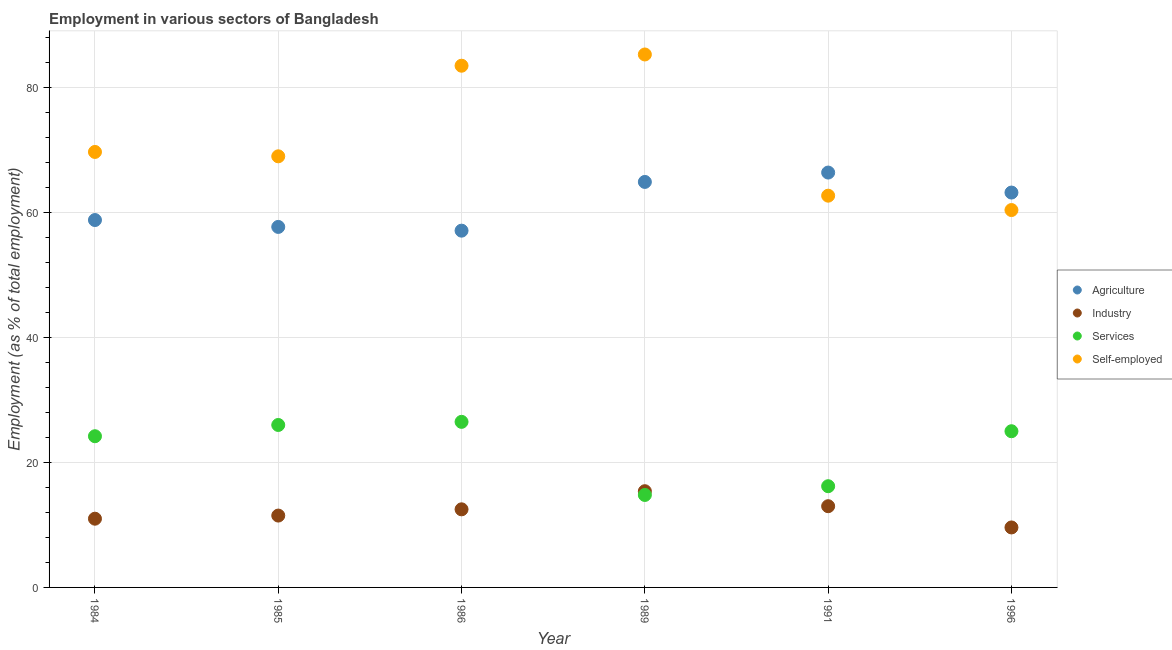How many different coloured dotlines are there?
Give a very brief answer. 4. What is the percentage of workers in industry in 1986?
Your response must be concise. 12.5. Across all years, what is the maximum percentage of workers in agriculture?
Your response must be concise. 66.4. Across all years, what is the minimum percentage of workers in agriculture?
Keep it short and to the point. 57.1. In which year was the percentage of workers in agriculture maximum?
Offer a very short reply. 1991. In which year was the percentage of workers in industry minimum?
Provide a succinct answer. 1996. What is the total percentage of workers in industry in the graph?
Make the answer very short. 73. What is the difference between the percentage of workers in industry in 1984 and that in 1996?
Keep it short and to the point. 1.4. What is the difference between the percentage of workers in services in 1984 and the percentage of workers in industry in 1991?
Keep it short and to the point. 11.2. What is the average percentage of workers in services per year?
Your answer should be very brief. 22.12. In the year 1991, what is the difference between the percentage of workers in services and percentage of self employed workers?
Offer a terse response. -46.5. In how many years, is the percentage of workers in agriculture greater than 4 %?
Make the answer very short. 6. What is the ratio of the percentage of workers in industry in 1986 to that in 1989?
Provide a succinct answer. 0.81. Is the percentage of workers in services in 1985 less than that in 1991?
Your answer should be compact. No. Is the difference between the percentage of workers in services in 1984 and 1985 greater than the difference between the percentage of workers in agriculture in 1984 and 1985?
Offer a terse response. No. What is the difference between the highest and the lowest percentage of workers in services?
Provide a short and direct response. 11.7. In how many years, is the percentage of self employed workers greater than the average percentage of self employed workers taken over all years?
Offer a terse response. 2. Is the sum of the percentage of self employed workers in 1986 and 1991 greater than the maximum percentage of workers in services across all years?
Ensure brevity in your answer.  Yes. Is it the case that in every year, the sum of the percentage of workers in services and percentage of workers in industry is greater than the sum of percentage of self employed workers and percentage of workers in agriculture?
Your answer should be very brief. No. Is the percentage of self employed workers strictly greater than the percentage of workers in agriculture over the years?
Make the answer very short. No. How many dotlines are there?
Give a very brief answer. 4. How many years are there in the graph?
Your answer should be very brief. 6. Where does the legend appear in the graph?
Your answer should be compact. Center right. How many legend labels are there?
Offer a very short reply. 4. What is the title of the graph?
Your answer should be compact. Employment in various sectors of Bangladesh. Does "Fish species" appear as one of the legend labels in the graph?
Provide a short and direct response. No. What is the label or title of the X-axis?
Keep it short and to the point. Year. What is the label or title of the Y-axis?
Give a very brief answer. Employment (as % of total employment). What is the Employment (as % of total employment) of Agriculture in 1984?
Give a very brief answer. 58.8. What is the Employment (as % of total employment) in Industry in 1984?
Give a very brief answer. 11. What is the Employment (as % of total employment) in Services in 1984?
Your answer should be compact. 24.2. What is the Employment (as % of total employment) of Self-employed in 1984?
Make the answer very short. 69.7. What is the Employment (as % of total employment) in Agriculture in 1985?
Make the answer very short. 57.7. What is the Employment (as % of total employment) of Industry in 1985?
Provide a succinct answer. 11.5. What is the Employment (as % of total employment) in Agriculture in 1986?
Ensure brevity in your answer.  57.1. What is the Employment (as % of total employment) of Industry in 1986?
Keep it short and to the point. 12.5. What is the Employment (as % of total employment) of Self-employed in 1986?
Make the answer very short. 83.5. What is the Employment (as % of total employment) of Agriculture in 1989?
Provide a short and direct response. 64.9. What is the Employment (as % of total employment) in Industry in 1989?
Keep it short and to the point. 15.4. What is the Employment (as % of total employment) in Services in 1989?
Ensure brevity in your answer.  14.8. What is the Employment (as % of total employment) in Self-employed in 1989?
Provide a succinct answer. 85.3. What is the Employment (as % of total employment) of Agriculture in 1991?
Provide a succinct answer. 66.4. What is the Employment (as % of total employment) of Industry in 1991?
Provide a succinct answer. 13. What is the Employment (as % of total employment) in Services in 1991?
Keep it short and to the point. 16.2. What is the Employment (as % of total employment) of Self-employed in 1991?
Provide a short and direct response. 62.7. What is the Employment (as % of total employment) in Agriculture in 1996?
Keep it short and to the point. 63.2. What is the Employment (as % of total employment) in Industry in 1996?
Offer a terse response. 9.6. What is the Employment (as % of total employment) in Self-employed in 1996?
Your answer should be very brief. 60.4. Across all years, what is the maximum Employment (as % of total employment) in Agriculture?
Offer a very short reply. 66.4. Across all years, what is the maximum Employment (as % of total employment) in Industry?
Your answer should be compact. 15.4. Across all years, what is the maximum Employment (as % of total employment) of Services?
Make the answer very short. 26.5. Across all years, what is the maximum Employment (as % of total employment) of Self-employed?
Provide a short and direct response. 85.3. Across all years, what is the minimum Employment (as % of total employment) of Agriculture?
Make the answer very short. 57.1. Across all years, what is the minimum Employment (as % of total employment) in Industry?
Make the answer very short. 9.6. Across all years, what is the minimum Employment (as % of total employment) in Services?
Ensure brevity in your answer.  14.8. Across all years, what is the minimum Employment (as % of total employment) of Self-employed?
Your answer should be very brief. 60.4. What is the total Employment (as % of total employment) in Agriculture in the graph?
Give a very brief answer. 368.1. What is the total Employment (as % of total employment) of Services in the graph?
Provide a short and direct response. 132.7. What is the total Employment (as % of total employment) in Self-employed in the graph?
Ensure brevity in your answer.  430.6. What is the difference between the Employment (as % of total employment) in Services in 1984 and that in 1986?
Your answer should be compact. -2.3. What is the difference between the Employment (as % of total employment) of Services in 1984 and that in 1989?
Offer a terse response. 9.4. What is the difference between the Employment (as % of total employment) of Self-employed in 1984 and that in 1989?
Offer a terse response. -15.6. What is the difference between the Employment (as % of total employment) of Services in 1984 and that in 1991?
Ensure brevity in your answer.  8. What is the difference between the Employment (as % of total employment) in Industry in 1984 and that in 1996?
Your response must be concise. 1.4. What is the difference between the Employment (as % of total employment) in Self-employed in 1984 and that in 1996?
Give a very brief answer. 9.3. What is the difference between the Employment (as % of total employment) in Agriculture in 1985 and that in 1986?
Your response must be concise. 0.6. What is the difference between the Employment (as % of total employment) of Services in 1985 and that in 1986?
Provide a succinct answer. -0.5. What is the difference between the Employment (as % of total employment) in Industry in 1985 and that in 1989?
Make the answer very short. -3.9. What is the difference between the Employment (as % of total employment) in Services in 1985 and that in 1989?
Your response must be concise. 11.2. What is the difference between the Employment (as % of total employment) of Self-employed in 1985 and that in 1989?
Provide a succinct answer. -16.3. What is the difference between the Employment (as % of total employment) in Industry in 1985 and that in 1991?
Offer a very short reply. -1.5. What is the difference between the Employment (as % of total employment) in Self-employed in 1985 and that in 1991?
Keep it short and to the point. 6.3. What is the difference between the Employment (as % of total employment) in Services in 1985 and that in 1996?
Keep it short and to the point. 1. What is the difference between the Employment (as % of total employment) in Self-employed in 1985 and that in 1996?
Make the answer very short. 8.6. What is the difference between the Employment (as % of total employment) in Agriculture in 1986 and that in 1989?
Offer a terse response. -7.8. What is the difference between the Employment (as % of total employment) in Self-employed in 1986 and that in 1989?
Provide a short and direct response. -1.8. What is the difference between the Employment (as % of total employment) of Agriculture in 1986 and that in 1991?
Your answer should be compact. -9.3. What is the difference between the Employment (as % of total employment) in Self-employed in 1986 and that in 1991?
Offer a terse response. 20.8. What is the difference between the Employment (as % of total employment) of Industry in 1986 and that in 1996?
Your answer should be compact. 2.9. What is the difference between the Employment (as % of total employment) of Services in 1986 and that in 1996?
Ensure brevity in your answer.  1.5. What is the difference between the Employment (as % of total employment) of Self-employed in 1986 and that in 1996?
Keep it short and to the point. 23.1. What is the difference between the Employment (as % of total employment) of Agriculture in 1989 and that in 1991?
Make the answer very short. -1.5. What is the difference between the Employment (as % of total employment) of Self-employed in 1989 and that in 1991?
Your answer should be compact. 22.6. What is the difference between the Employment (as % of total employment) of Industry in 1989 and that in 1996?
Make the answer very short. 5.8. What is the difference between the Employment (as % of total employment) of Self-employed in 1989 and that in 1996?
Ensure brevity in your answer.  24.9. What is the difference between the Employment (as % of total employment) of Agriculture in 1991 and that in 1996?
Provide a succinct answer. 3.2. What is the difference between the Employment (as % of total employment) of Self-employed in 1991 and that in 1996?
Keep it short and to the point. 2.3. What is the difference between the Employment (as % of total employment) of Agriculture in 1984 and the Employment (as % of total employment) of Industry in 1985?
Ensure brevity in your answer.  47.3. What is the difference between the Employment (as % of total employment) in Agriculture in 1984 and the Employment (as % of total employment) in Services in 1985?
Offer a very short reply. 32.8. What is the difference between the Employment (as % of total employment) of Industry in 1984 and the Employment (as % of total employment) of Services in 1985?
Your answer should be compact. -15. What is the difference between the Employment (as % of total employment) of Industry in 1984 and the Employment (as % of total employment) of Self-employed in 1985?
Offer a terse response. -58. What is the difference between the Employment (as % of total employment) in Services in 1984 and the Employment (as % of total employment) in Self-employed in 1985?
Ensure brevity in your answer.  -44.8. What is the difference between the Employment (as % of total employment) of Agriculture in 1984 and the Employment (as % of total employment) of Industry in 1986?
Offer a very short reply. 46.3. What is the difference between the Employment (as % of total employment) in Agriculture in 1984 and the Employment (as % of total employment) in Services in 1986?
Make the answer very short. 32.3. What is the difference between the Employment (as % of total employment) in Agriculture in 1984 and the Employment (as % of total employment) in Self-employed in 1986?
Your answer should be compact. -24.7. What is the difference between the Employment (as % of total employment) in Industry in 1984 and the Employment (as % of total employment) in Services in 1986?
Give a very brief answer. -15.5. What is the difference between the Employment (as % of total employment) in Industry in 1984 and the Employment (as % of total employment) in Self-employed in 1986?
Make the answer very short. -72.5. What is the difference between the Employment (as % of total employment) of Services in 1984 and the Employment (as % of total employment) of Self-employed in 1986?
Keep it short and to the point. -59.3. What is the difference between the Employment (as % of total employment) of Agriculture in 1984 and the Employment (as % of total employment) of Industry in 1989?
Offer a terse response. 43.4. What is the difference between the Employment (as % of total employment) of Agriculture in 1984 and the Employment (as % of total employment) of Services in 1989?
Keep it short and to the point. 44. What is the difference between the Employment (as % of total employment) in Agriculture in 1984 and the Employment (as % of total employment) in Self-employed in 1989?
Make the answer very short. -26.5. What is the difference between the Employment (as % of total employment) of Industry in 1984 and the Employment (as % of total employment) of Services in 1989?
Give a very brief answer. -3.8. What is the difference between the Employment (as % of total employment) of Industry in 1984 and the Employment (as % of total employment) of Self-employed in 1989?
Your answer should be very brief. -74.3. What is the difference between the Employment (as % of total employment) in Services in 1984 and the Employment (as % of total employment) in Self-employed in 1989?
Your answer should be compact. -61.1. What is the difference between the Employment (as % of total employment) of Agriculture in 1984 and the Employment (as % of total employment) of Industry in 1991?
Provide a short and direct response. 45.8. What is the difference between the Employment (as % of total employment) of Agriculture in 1984 and the Employment (as % of total employment) of Services in 1991?
Offer a very short reply. 42.6. What is the difference between the Employment (as % of total employment) of Agriculture in 1984 and the Employment (as % of total employment) of Self-employed in 1991?
Provide a succinct answer. -3.9. What is the difference between the Employment (as % of total employment) in Industry in 1984 and the Employment (as % of total employment) in Self-employed in 1991?
Your response must be concise. -51.7. What is the difference between the Employment (as % of total employment) of Services in 1984 and the Employment (as % of total employment) of Self-employed in 1991?
Provide a short and direct response. -38.5. What is the difference between the Employment (as % of total employment) in Agriculture in 1984 and the Employment (as % of total employment) in Industry in 1996?
Offer a terse response. 49.2. What is the difference between the Employment (as % of total employment) of Agriculture in 1984 and the Employment (as % of total employment) of Services in 1996?
Provide a short and direct response. 33.8. What is the difference between the Employment (as % of total employment) of Industry in 1984 and the Employment (as % of total employment) of Services in 1996?
Your answer should be compact. -14. What is the difference between the Employment (as % of total employment) of Industry in 1984 and the Employment (as % of total employment) of Self-employed in 1996?
Your answer should be very brief. -49.4. What is the difference between the Employment (as % of total employment) of Services in 1984 and the Employment (as % of total employment) of Self-employed in 1996?
Provide a succinct answer. -36.2. What is the difference between the Employment (as % of total employment) of Agriculture in 1985 and the Employment (as % of total employment) of Industry in 1986?
Ensure brevity in your answer.  45.2. What is the difference between the Employment (as % of total employment) of Agriculture in 1985 and the Employment (as % of total employment) of Services in 1986?
Provide a short and direct response. 31.2. What is the difference between the Employment (as % of total employment) of Agriculture in 1985 and the Employment (as % of total employment) of Self-employed in 1986?
Offer a very short reply. -25.8. What is the difference between the Employment (as % of total employment) of Industry in 1985 and the Employment (as % of total employment) of Self-employed in 1986?
Offer a very short reply. -72. What is the difference between the Employment (as % of total employment) of Services in 1985 and the Employment (as % of total employment) of Self-employed in 1986?
Offer a terse response. -57.5. What is the difference between the Employment (as % of total employment) in Agriculture in 1985 and the Employment (as % of total employment) in Industry in 1989?
Give a very brief answer. 42.3. What is the difference between the Employment (as % of total employment) in Agriculture in 1985 and the Employment (as % of total employment) in Services in 1989?
Provide a succinct answer. 42.9. What is the difference between the Employment (as % of total employment) in Agriculture in 1985 and the Employment (as % of total employment) in Self-employed in 1989?
Your answer should be very brief. -27.6. What is the difference between the Employment (as % of total employment) in Industry in 1985 and the Employment (as % of total employment) in Self-employed in 1989?
Offer a very short reply. -73.8. What is the difference between the Employment (as % of total employment) in Services in 1985 and the Employment (as % of total employment) in Self-employed in 1989?
Your answer should be very brief. -59.3. What is the difference between the Employment (as % of total employment) in Agriculture in 1985 and the Employment (as % of total employment) in Industry in 1991?
Offer a very short reply. 44.7. What is the difference between the Employment (as % of total employment) of Agriculture in 1985 and the Employment (as % of total employment) of Services in 1991?
Ensure brevity in your answer.  41.5. What is the difference between the Employment (as % of total employment) of Industry in 1985 and the Employment (as % of total employment) of Self-employed in 1991?
Offer a terse response. -51.2. What is the difference between the Employment (as % of total employment) in Services in 1985 and the Employment (as % of total employment) in Self-employed in 1991?
Give a very brief answer. -36.7. What is the difference between the Employment (as % of total employment) in Agriculture in 1985 and the Employment (as % of total employment) in Industry in 1996?
Keep it short and to the point. 48.1. What is the difference between the Employment (as % of total employment) of Agriculture in 1985 and the Employment (as % of total employment) of Services in 1996?
Ensure brevity in your answer.  32.7. What is the difference between the Employment (as % of total employment) of Industry in 1985 and the Employment (as % of total employment) of Services in 1996?
Give a very brief answer. -13.5. What is the difference between the Employment (as % of total employment) in Industry in 1985 and the Employment (as % of total employment) in Self-employed in 1996?
Provide a succinct answer. -48.9. What is the difference between the Employment (as % of total employment) of Services in 1985 and the Employment (as % of total employment) of Self-employed in 1996?
Your answer should be very brief. -34.4. What is the difference between the Employment (as % of total employment) of Agriculture in 1986 and the Employment (as % of total employment) of Industry in 1989?
Provide a succinct answer. 41.7. What is the difference between the Employment (as % of total employment) in Agriculture in 1986 and the Employment (as % of total employment) in Services in 1989?
Your answer should be very brief. 42.3. What is the difference between the Employment (as % of total employment) in Agriculture in 1986 and the Employment (as % of total employment) in Self-employed in 1989?
Your response must be concise. -28.2. What is the difference between the Employment (as % of total employment) of Industry in 1986 and the Employment (as % of total employment) of Self-employed in 1989?
Keep it short and to the point. -72.8. What is the difference between the Employment (as % of total employment) of Services in 1986 and the Employment (as % of total employment) of Self-employed in 1989?
Offer a very short reply. -58.8. What is the difference between the Employment (as % of total employment) in Agriculture in 1986 and the Employment (as % of total employment) in Industry in 1991?
Offer a very short reply. 44.1. What is the difference between the Employment (as % of total employment) of Agriculture in 1986 and the Employment (as % of total employment) of Services in 1991?
Your response must be concise. 40.9. What is the difference between the Employment (as % of total employment) of Agriculture in 1986 and the Employment (as % of total employment) of Self-employed in 1991?
Offer a terse response. -5.6. What is the difference between the Employment (as % of total employment) of Industry in 1986 and the Employment (as % of total employment) of Services in 1991?
Provide a short and direct response. -3.7. What is the difference between the Employment (as % of total employment) in Industry in 1986 and the Employment (as % of total employment) in Self-employed in 1991?
Your answer should be very brief. -50.2. What is the difference between the Employment (as % of total employment) in Services in 1986 and the Employment (as % of total employment) in Self-employed in 1991?
Your answer should be very brief. -36.2. What is the difference between the Employment (as % of total employment) in Agriculture in 1986 and the Employment (as % of total employment) in Industry in 1996?
Make the answer very short. 47.5. What is the difference between the Employment (as % of total employment) in Agriculture in 1986 and the Employment (as % of total employment) in Services in 1996?
Provide a succinct answer. 32.1. What is the difference between the Employment (as % of total employment) in Agriculture in 1986 and the Employment (as % of total employment) in Self-employed in 1996?
Provide a short and direct response. -3.3. What is the difference between the Employment (as % of total employment) in Industry in 1986 and the Employment (as % of total employment) in Services in 1996?
Offer a terse response. -12.5. What is the difference between the Employment (as % of total employment) in Industry in 1986 and the Employment (as % of total employment) in Self-employed in 1996?
Give a very brief answer. -47.9. What is the difference between the Employment (as % of total employment) of Services in 1986 and the Employment (as % of total employment) of Self-employed in 1996?
Keep it short and to the point. -33.9. What is the difference between the Employment (as % of total employment) of Agriculture in 1989 and the Employment (as % of total employment) of Industry in 1991?
Your answer should be compact. 51.9. What is the difference between the Employment (as % of total employment) in Agriculture in 1989 and the Employment (as % of total employment) in Services in 1991?
Provide a short and direct response. 48.7. What is the difference between the Employment (as % of total employment) of Industry in 1989 and the Employment (as % of total employment) of Self-employed in 1991?
Your answer should be very brief. -47.3. What is the difference between the Employment (as % of total employment) in Services in 1989 and the Employment (as % of total employment) in Self-employed in 1991?
Provide a succinct answer. -47.9. What is the difference between the Employment (as % of total employment) in Agriculture in 1989 and the Employment (as % of total employment) in Industry in 1996?
Provide a short and direct response. 55.3. What is the difference between the Employment (as % of total employment) in Agriculture in 1989 and the Employment (as % of total employment) in Services in 1996?
Make the answer very short. 39.9. What is the difference between the Employment (as % of total employment) of Industry in 1989 and the Employment (as % of total employment) of Self-employed in 1996?
Make the answer very short. -45. What is the difference between the Employment (as % of total employment) in Services in 1989 and the Employment (as % of total employment) in Self-employed in 1996?
Make the answer very short. -45.6. What is the difference between the Employment (as % of total employment) of Agriculture in 1991 and the Employment (as % of total employment) of Industry in 1996?
Offer a very short reply. 56.8. What is the difference between the Employment (as % of total employment) of Agriculture in 1991 and the Employment (as % of total employment) of Services in 1996?
Make the answer very short. 41.4. What is the difference between the Employment (as % of total employment) in Agriculture in 1991 and the Employment (as % of total employment) in Self-employed in 1996?
Offer a very short reply. 6. What is the difference between the Employment (as % of total employment) of Industry in 1991 and the Employment (as % of total employment) of Services in 1996?
Provide a short and direct response. -12. What is the difference between the Employment (as % of total employment) of Industry in 1991 and the Employment (as % of total employment) of Self-employed in 1996?
Your response must be concise. -47.4. What is the difference between the Employment (as % of total employment) in Services in 1991 and the Employment (as % of total employment) in Self-employed in 1996?
Your answer should be very brief. -44.2. What is the average Employment (as % of total employment) in Agriculture per year?
Your answer should be compact. 61.35. What is the average Employment (as % of total employment) in Industry per year?
Give a very brief answer. 12.17. What is the average Employment (as % of total employment) in Services per year?
Your answer should be very brief. 22.12. What is the average Employment (as % of total employment) in Self-employed per year?
Offer a terse response. 71.77. In the year 1984, what is the difference between the Employment (as % of total employment) of Agriculture and Employment (as % of total employment) of Industry?
Make the answer very short. 47.8. In the year 1984, what is the difference between the Employment (as % of total employment) in Agriculture and Employment (as % of total employment) in Services?
Your answer should be very brief. 34.6. In the year 1984, what is the difference between the Employment (as % of total employment) in Industry and Employment (as % of total employment) in Self-employed?
Your answer should be very brief. -58.7. In the year 1984, what is the difference between the Employment (as % of total employment) of Services and Employment (as % of total employment) of Self-employed?
Offer a very short reply. -45.5. In the year 1985, what is the difference between the Employment (as % of total employment) of Agriculture and Employment (as % of total employment) of Industry?
Ensure brevity in your answer.  46.2. In the year 1985, what is the difference between the Employment (as % of total employment) of Agriculture and Employment (as % of total employment) of Services?
Your response must be concise. 31.7. In the year 1985, what is the difference between the Employment (as % of total employment) of Industry and Employment (as % of total employment) of Self-employed?
Make the answer very short. -57.5. In the year 1985, what is the difference between the Employment (as % of total employment) of Services and Employment (as % of total employment) of Self-employed?
Ensure brevity in your answer.  -43. In the year 1986, what is the difference between the Employment (as % of total employment) of Agriculture and Employment (as % of total employment) of Industry?
Offer a terse response. 44.6. In the year 1986, what is the difference between the Employment (as % of total employment) of Agriculture and Employment (as % of total employment) of Services?
Make the answer very short. 30.6. In the year 1986, what is the difference between the Employment (as % of total employment) in Agriculture and Employment (as % of total employment) in Self-employed?
Your response must be concise. -26.4. In the year 1986, what is the difference between the Employment (as % of total employment) in Industry and Employment (as % of total employment) in Self-employed?
Offer a very short reply. -71. In the year 1986, what is the difference between the Employment (as % of total employment) in Services and Employment (as % of total employment) in Self-employed?
Make the answer very short. -57. In the year 1989, what is the difference between the Employment (as % of total employment) of Agriculture and Employment (as % of total employment) of Industry?
Keep it short and to the point. 49.5. In the year 1989, what is the difference between the Employment (as % of total employment) of Agriculture and Employment (as % of total employment) of Services?
Ensure brevity in your answer.  50.1. In the year 1989, what is the difference between the Employment (as % of total employment) of Agriculture and Employment (as % of total employment) of Self-employed?
Your response must be concise. -20.4. In the year 1989, what is the difference between the Employment (as % of total employment) of Industry and Employment (as % of total employment) of Self-employed?
Ensure brevity in your answer.  -69.9. In the year 1989, what is the difference between the Employment (as % of total employment) of Services and Employment (as % of total employment) of Self-employed?
Offer a terse response. -70.5. In the year 1991, what is the difference between the Employment (as % of total employment) in Agriculture and Employment (as % of total employment) in Industry?
Offer a terse response. 53.4. In the year 1991, what is the difference between the Employment (as % of total employment) in Agriculture and Employment (as % of total employment) in Services?
Ensure brevity in your answer.  50.2. In the year 1991, what is the difference between the Employment (as % of total employment) in Agriculture and Employment (as % of total employment) in Self-employed?
Make the answer very short. 3.7. In the year 1991, what is the difference between the Employment (as % of total employment) in Industry and Employment (as % of total employment) in Services?
Give a very brief answer. -3.2. In the year 1991, what is the difference between the Employment (as % of total employment) of Industry and Employment (as % of total employment) of Self-employed?
Keep it short and to the point. -49.7. In the year 1991, what is the difference between the Employment (as % of total employment) in Services and Employment (as % of total employment) in Self-employed?
Your answer should be compact. -46.5. In the year 1996, what is the difference between the Employment (as % of total employment) in Agriculture and Employment (as % of total employment) in Industry?
Your answer should be very brief. 53.6. In the year 1996, what is the difference between the Employment (as % of total employment) of Agriculture and Employment (as % of total employment) of Services?
Provide a succinct answer. 38.2. In the year 1996, what is the difference between the Employment (as % of total employment) in Industry and Employment (as % of total employment) in Services?
Your response must be concise. -15.4. In the year 1996, what is the difference between the Employment (as % of total employment) in Industry and Employment (as % of total employment) in Self-employed?
Provide a short and direct response. -50.8. In the year 1996, what is the difference between the Employment (as % of total employment) in Services and Employment (as % of total employment) in Self-employed?
Give a very brief answer. -35.4. What is the ratio of the Employment (as % of total employment) in Agriculture in 1984 to that in 1985?
Your response must be concise. 1.02. What is the ratio of the Employment (as % of total employment) of Industry in 1984 to that in 1985?
Ensure brevity in your answer.  0.96. What is the ratio of the Employment (as % of total employment) in Services in 1984 to that in 1985?
Offer a very short reply. 0.93. What is the ratio of the Employment (as % of total employment) of Self-employed in 1984 to that in 1985?
Make the answer very short. 1.01. What is the ratio of the Employment (as % of total employment) of Agriculture in 1984 to that in 1986?
Keep it short and to the point. 1.03. What is the ratio of the Employment (as % of total employment) of Services in 1984 to that in 1986?
Make the answer very short. 0.91. What is the ratio of the Employment (as % of total employment) of Self-employed in 1984 to that in 1986?
Make the answer very short. 0.83. What is the ratio of the Employment (as % of total employment) of Agriculture in 1984 to that in 1989?
Your response must be concise. 0.91. What is the ratio of the Employment (as % of total employment) in Industry in 1984 to that in 1989?
Your response must be concise. 0.71. What is the ratio of the Employment (as % of total employment) in Services in 1984 to that in 1989?
Your answer should be very brief. 1.64. What is the ratio of the Employment (as % of total employment) of Self-employed in 1984 to that in 1989?
Your answer should be compact. 0.82. What is the ratio of the Employment (as % of total employment) of Agriculture in 1984 to that in 1991?
Keep it short and to the point. 0.89. What is the ratio of the Employment (as % of total employment) in Industry in 1984 to that in 1991?
Provide a succinct answer. 0.85. What is the ratio of the Employment (as % of total employment) in Services in 1984 to that in 1991?
Keep it short and to the point. 1.49. What is the ratio of the Employment (as % of total employment) of Self-employed in 1984 to that in 1991?
Provide a short and direct response. 1.11. What is the ratio of the Employment (as % of total employment) in Agriculture in 1984 to that in 1996?
Your answer should be compact. 0.93. What is the ratio of the Employment (as % of total employment) in Industry in 1984 to that in 1996?
Your answer should be compact. 1.15. What is the ratio of the Employment (as % of total employment) of Services in 1984 to that in 1996?
Keep it short and to the point. 0.97. What is the ratio of the Employment (as % of total employment) in Self-employed in 1984 to that in 1996?
Your answer should be compact. 1.15. What is the ratio of the Employment (as % of total employment) in Agriculture in 1985 to that in 1986?
Keep it short and to the point. 1.01. What is the ratio of the Employment (as % of total employment) of Services in 1985 to that in 1986?
Your response must be concise. 0.98. What is the ratio of the Employment (as % of total employment) in Self-employed in 1985 to that in 1986?
Provide a short and direct response. 0.83. What is the ratio of the Employment (as % of total employment) of Agriculture in 1985 to that in 1989?
Give a very brief answer. 0.89. What is the ratio of the Employment (as % of total employment) of Industry in 1985 to that in 1989?
Offer a terse response. 0.75. What is the ratio of the Employment (as % of total employment) of Services in 1985 to that in 1989?
Make the answer very short. 1.76. What is the ratio of the Employment (as % of total employment) of Self-employed in 1985 to that in 1989?
Keep it short and to the point. 0.81. What is the ratio of the Employment (as % of total employment) in Agriculture in 1985 to that in 1991?
Keep it short and to the point. 0.87. What is the ratio of the Employment (as % of total employment) of Industry in 1985 to that in 1991?
Ensure brevity in your answer.  0.88. What is the ratio of the Employment (as % of total employment) of Services in 1985 to that in 1991?
Provide a short and direct response. 1.6. What is the ratio of the Employment (as % of total employment) of Self-employed in 1985 to that in 1991?
Provide a succinct answer. 1.1. What is the ratio of the Employment (as % of total employment) of Industry in 1985 to that in 1996?
Provide a short and direct response. 1.2. What is the ratio of the Employment (as % of total employment) in Self-employed in 1985 to that in 1996?
Offer a very short reply. 1.14. What is the ratio of the Employment (as % of total employment) of Agriculture in 1986 to that in 1989?
Your response must be concise. 0.88. What is the ratio of the Employment (as % of total employment) in Industry in 1986 to that in 1989?
Offer a terse response. 0.81. What is the ratio of the Employment (as % of total employment) of Services in 1986 to that in 1989?
Your answer should be very brief. 1.79. What is the ratio of the Employment (as % of total employment) of Self-employed in 1986 to that in 1989?
Keep it short and to the point. 0.98. What is the ratio of the Employment (as % of total employment) of Agriculture in 1986 to that in 1991?
Keep it short and to the point. 0.86. What is the ratio of the Employment (as % of total employment) in Industry in 1986 to that in 1991?
Your answer should be very brief. 0.96. What is the ratio of the Employment (as % of total employment) of Services in 1986 to that in 1991?
Offer a very short reply. 1.64. What is the ratio of the Employment (as % of total employment) of Self-employed in 1986 to that in 1991?
Offer a very short reply. 1.33. What is the ratio of the Employment (as % of total employment) in Agriculture in 1986 to that in 1996?
Offer a terse response. 0.9. What is the ratio of the Employment (as % of total employment) in Industry in 1986 to that in 1996?
Offer a very short reply. 1.3. What is the ratio of the Employment (as % of total employment) in Services in 1986 to that in 1996?
Offer a terse response. 1.06. What is the ratio of the Employment (as % of total employment) of Self-employed in 1986 to that in 1996?
Your response must be concise. 1.38. What is the ratio of the Employment (as % of total employment) in Agriculture in 1989 to that in 1991?
Keep it short and to the point. 0.98. What is the ratio of the Employment (as % of total employment) in Industry in 1989 to that in 1991?
Your answer should be very brief. 1.18. What is the ratio of the Employment (as % of total employment) of Services in 1989 to that in 1991?
Make the answer very short. 0.91. What is the ratio of the Employment (as % of total employment) in Self-employed in 1989 to that in 1991?
Provide a succinct answer. 1.36. What is the ratio of the Employment (as % of total employment) of Agriculture in 1989 to that in 1996?
Provide a succinct answer. 1.03. What is the ratio of the Employment (as % of total employment) of Industry in 1989 to that in 1996?
Give a very brief answer. 1.6. What is the ratio of the Employment (as % of total employment) in Services in 1989 to that in 1996?
Your answer should be very brief. 0.59. What is the ratio of the Employment (as % of total employment) of Self-employed in 1989 to that in 1996?
Ensure brevity in your answer.  1.41. What is the ratio of the Employment (as % of total employment) in Agriculture in 1991 to that in 1996?
Keep it short and to the point. 1.05. What is the ratio of the Employment (as % of total employment) of Industry in 1991 to that in 1996?
Offer a terse response. 1.35. What is the ratio of the Employment (as % of total employment) of Services in 1991 to that in 1996?
Give a very brief answer. 0.65. What is the ratio of the Employment (as % of total employment) of Self-employed in 1991 to that in 1996?
Provide a succinct answer. 1.04. What is the difference between the highest and the second highest Employment (as % of total employment) of Agriculture?
Offer a very short reply. 1.5. What is the difference between the highest and the second highest Employment (as % of total employment) in Services?
Keep it short and to the point. 0.5. What is the difference between the highest and the second highest Employment (as % of total employment) of Self-employed?
Provide a short and direct response. 1.8. What is the difference between the highest and the lowest Employment (as % of total employment) in Agriculture?
Provide a succinct answer. 9.3. What is the difference between the highest and the lowest Employment (as % of total employment) of Industry?
Your answer should be compact. 5.8. What is the difference between the highest and the lowest Employment (as % of total employment) of Self-employed?
Ensure brevity in your answer.  24.9. 